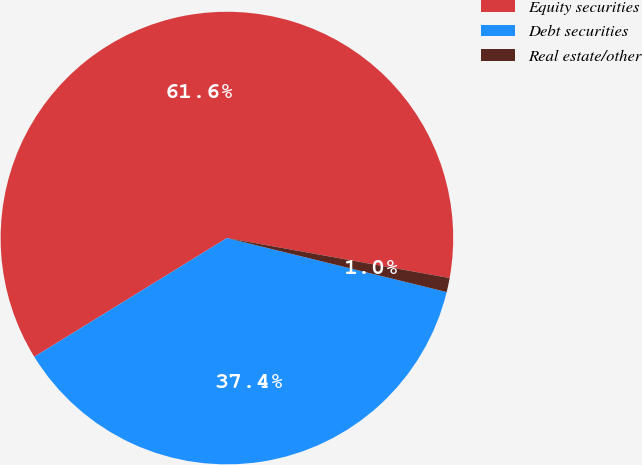<chart> <loc_0><loc_0><loc_500><loc_500><pie_chart><fcel>Equity securities<fcel>Debt securities<fcel>Real estate/other<nl><fcel>61.62%<fcel>37.37%<fcel>1.01%<nl></chart> 